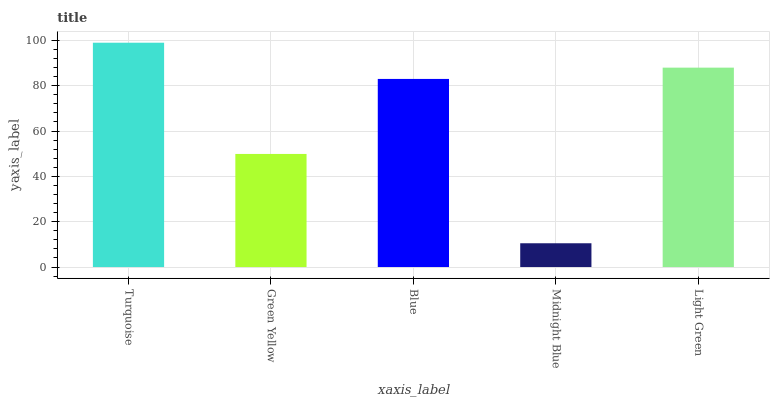Is Midnight Blue the minimum?
Answer yes or no. Yes. Is Turquoise the maximum?
Answer yes or no. Yes. Is Green Yellow the minimum?
Answer yes or no. No. Is Green Yellow the maximum?
Answer yes or no. No. Is Turquoise greater than Green Yellow?
Answer yes or no. Yes. Is Green Yellow less than Turquoise?
Answer yes or no. Yes. Is Green Yellow greater than Turquoise?
Answer yes or no. No. Is Turquoise less than Green Yellow?
Answer yes or no. No. Is Blue the high median?
Answer yes or no. Yes. Is Blue the low median?
Answer yes or no. Yes. Is Turquoise the high median?
Answer yes or no. No. Is Green Yellow the low median?
Answer yes or no. No. 